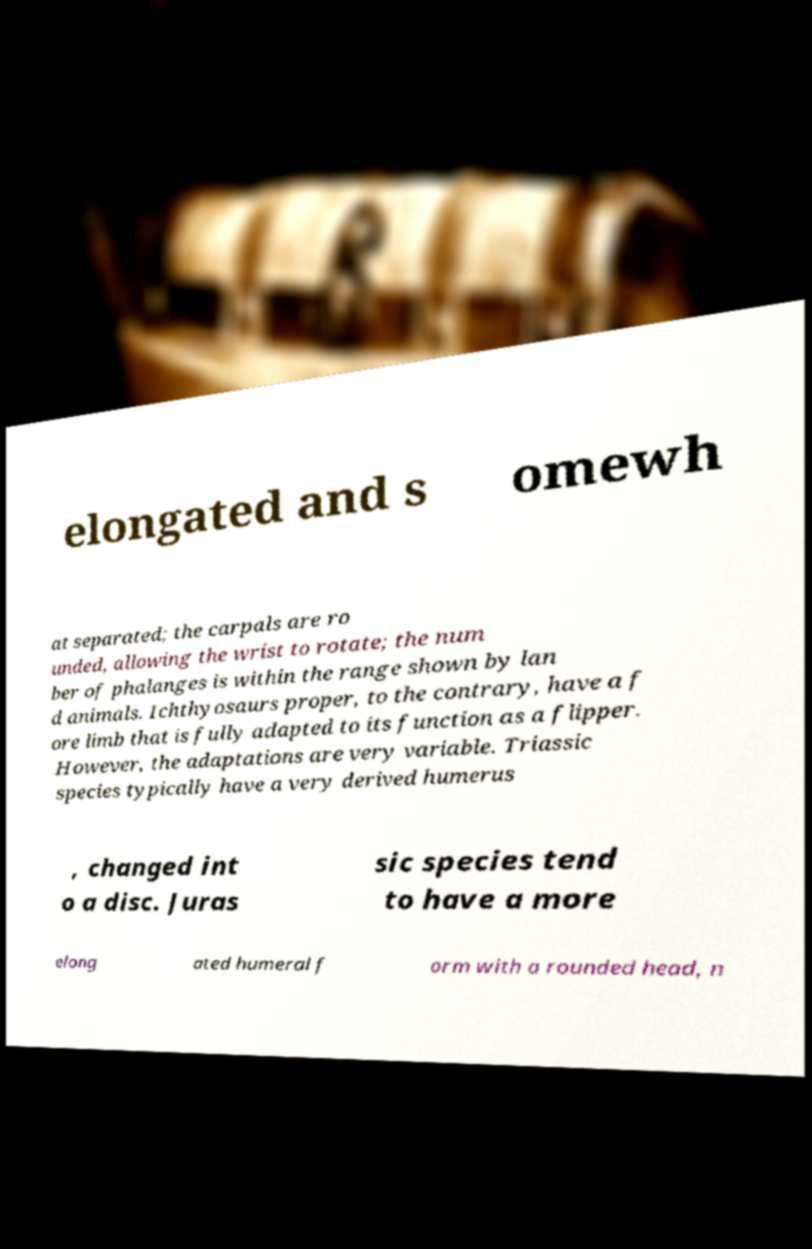Please read and relay the text visible in this image. What does it say? elongated and s omewh at separated; the carpals are ro unded, allowing the wrist to rotate; the num ber of phalanges is within the range shown by lan d animals. Ichthyosaurs proper, to the contrary, have a f ore limb that is fully adapted to its function as a flipper. However, the adaptations are very variable. Triassic species typically have a very derived humerus , changed int o a disc. Juras sic species tend to have a more elong ated humeral f orm with a rounded head, n 